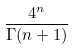Convert formula to latex. <formula><loc_0><loc_0><loc_500><loc_500>\frac { 4 ^ { n } } { \Gamma ( n + 1 ) }</formula> 